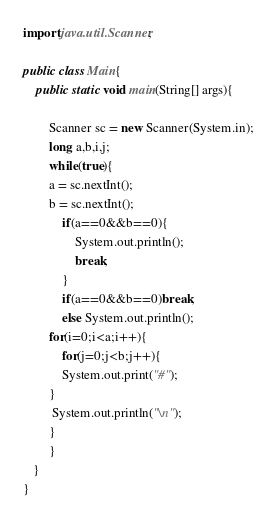<code> <loc_0><loc_0><loc_500><loc_500><_Java_>import java.util.Scanner;

public class Main{
	public static void main(String[] args){
        
        Scanner sc = new Scanner(System.in);
        long a,b,i,j;
		while(true){
        a = sc.nextInt();
        b = sc.nextInt();
            if(a==0&&b==0){
                System.out.println();
                break;
            }
            if(a==0&&b==0)break;
            else System.out.println();
		for(i=0;i<a;i++){
            for(j=0;j<b;j++){
            System.out.print("#");
        } 
         System.out.println("\n");
        }
        }
   }
}
</code> 